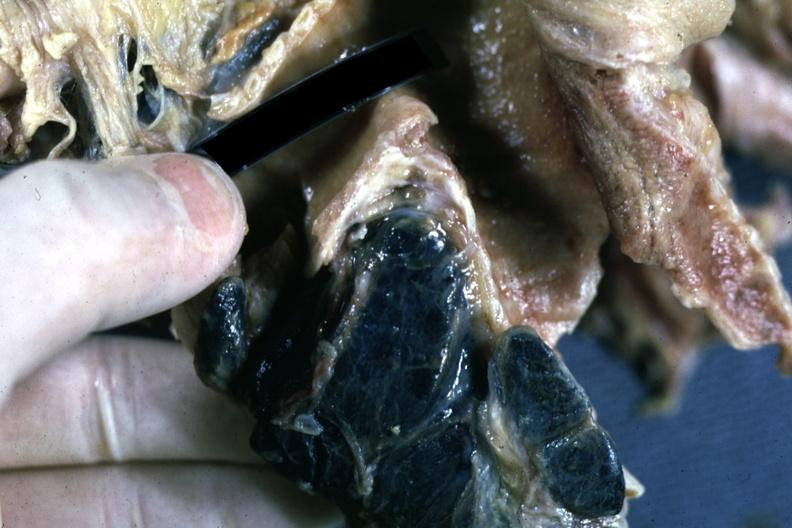s leiomyoma present?
Answer the question using a single word or phrase. No 